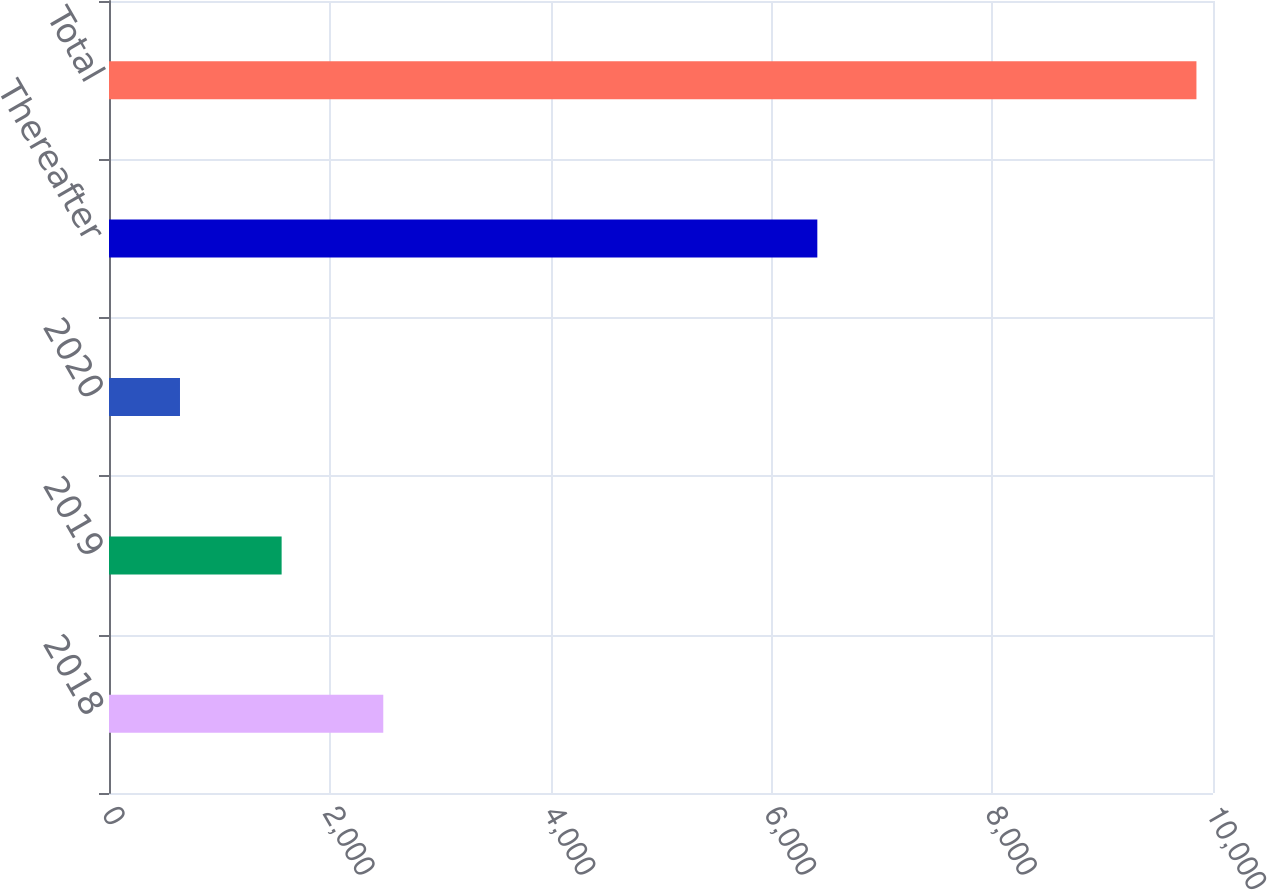Convert chart to OTSL. <chart><loc_0><loc_0><loc_500><loc_500><bar_chart><fcel>2018<fcel>2019<fcel>2020<fcel>Thereafter<fcel>Total<nl><fcel>2484.4<fcel>1563.7<fcel>643<fcel>6416<fcel>9850<nl></chart> 